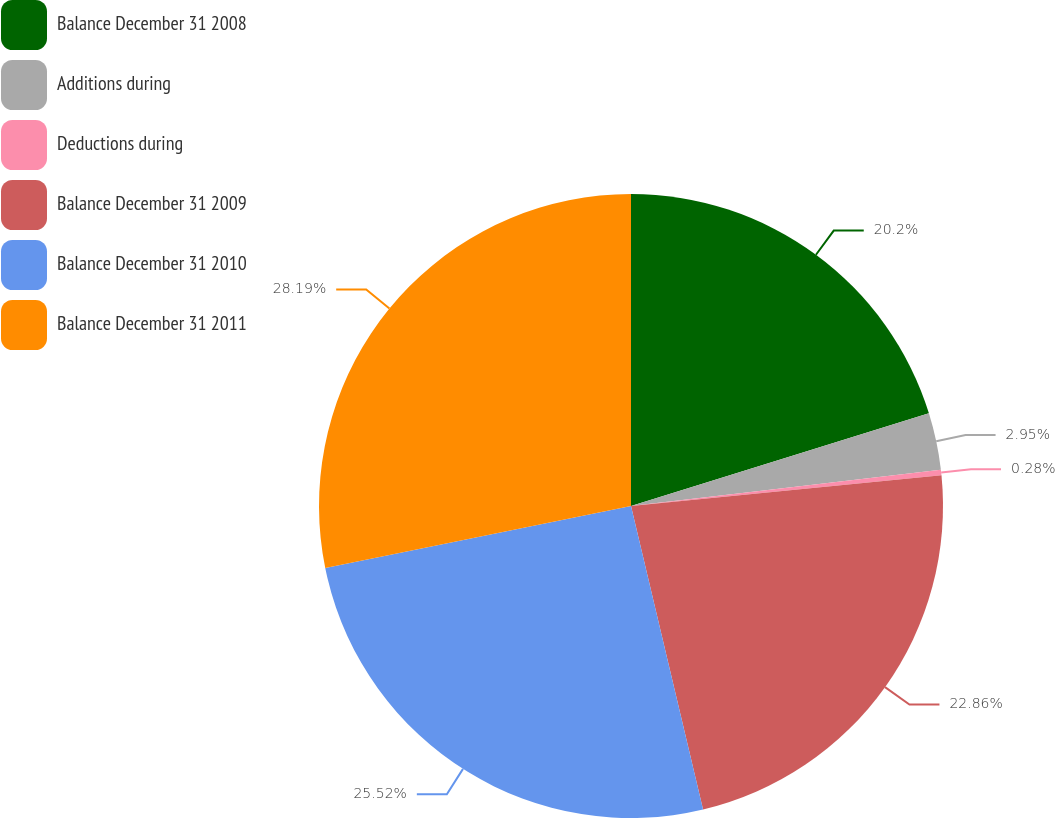Convert chart to OTSL. <chart><loc_0><loc_0><loc_500><loc_500><pie_chart><fcel>Balance December 31 2008<fcel>Additions during<fcel>Deductions during<fcel>Balance December 31 2009<fcel>Balance December 31 2010<fcel>Balance December 31 2011<nl><fcel>20.2%<fcel>2.95%<fcel>0.28%<fcel>22.86%<fcel>25.52%<fcel>28.19%<nl></chart> 